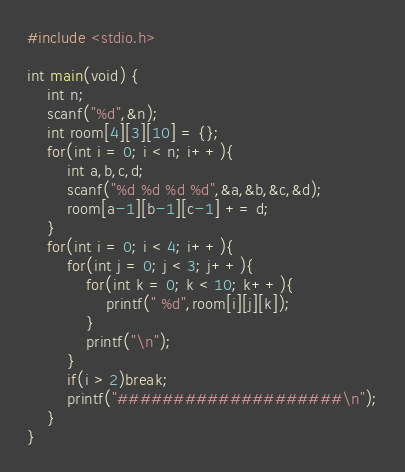<code> <loc_0><loc_0><loc_500><loc_500><_C_>#include <stdio.h>

int main(void) {
	int n;
	scanf("%d",&n);
	int room[4][3][10] = {};
	for(int i = 0; i < n; i++){
		int a,b,c,d;
		scanf("%d %d %d %d",&a,&b,&c,&d);
		room[a-1][b-1][c-1] += d;
	}
	for(int i = 0; i < 4; i++){
		for(int j = 0; j < 3; j++){
			for(int k = 0; k < 10; k++){
				printf(" %d",room[i][j][k]);
			}
			printf("\n");
		}
		if(i > 2)break;
		printf("####################\n");
	}
}
</code> 